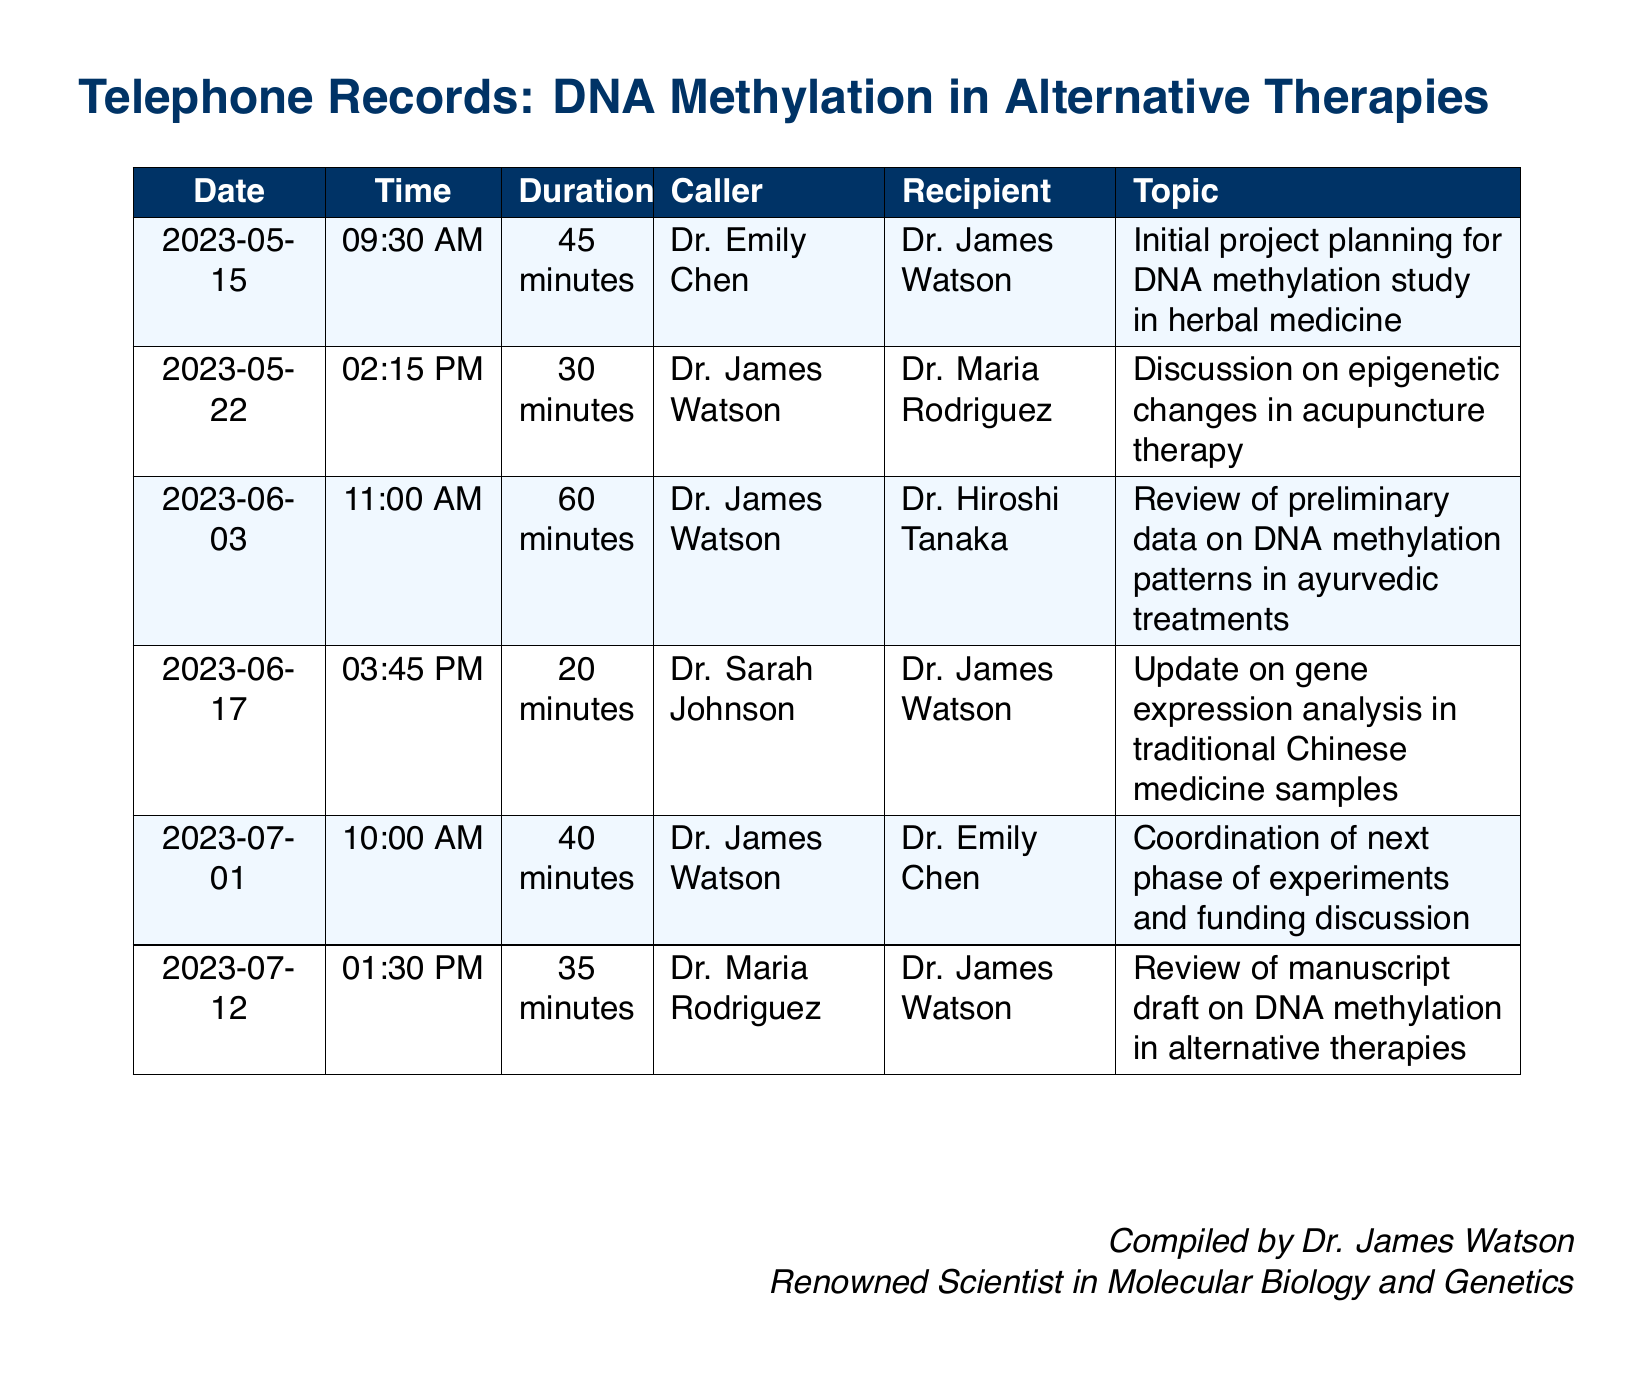What is the duration of the call on June 3, 2023? The duration of the call on June 3, 2023, is stated in the document for that specific date.
Answer: 60 minutes Who called Dr. James Watson on July 1, 2023? The document provides the caller's name for each entry on that date.
Answer: Dr. Emily Chen What is the topic of the call on May 22, 2023? The topic of each call is detailed in the table for that date.
Answer: Discussion on epigenetic changes in acupuncture therapy How many calls were made in June 2023? By counting the entries in the document for June 2023, you can find the total number of calls.
Answer: 3 calls Which doctor discussed the funding on July 1, 2023? The document specifies the participants in each call, indicating who discussed funding.
Answer: Dr. Emily Chen What date did the call regarding manuscript review take place? The date of each call is clearly indicated in the document.
Answer: July 12, 2023 What was the main focus of the call on May 15, 2023? The main focus or topic of each call is clearly outlined in the document.
Answer: Initial project planning for DNA methylation study in herbal medicine Who was the recipient of the call on June 17, 2023? The recipient's name for each call is listed in the document for that date.
Answer: Dr. James Watson What time did the call with Dr. Sarah Johnson occur? The time of the call is explicitly mentioned in the document for each entry.
Answer: 03:45 PM 